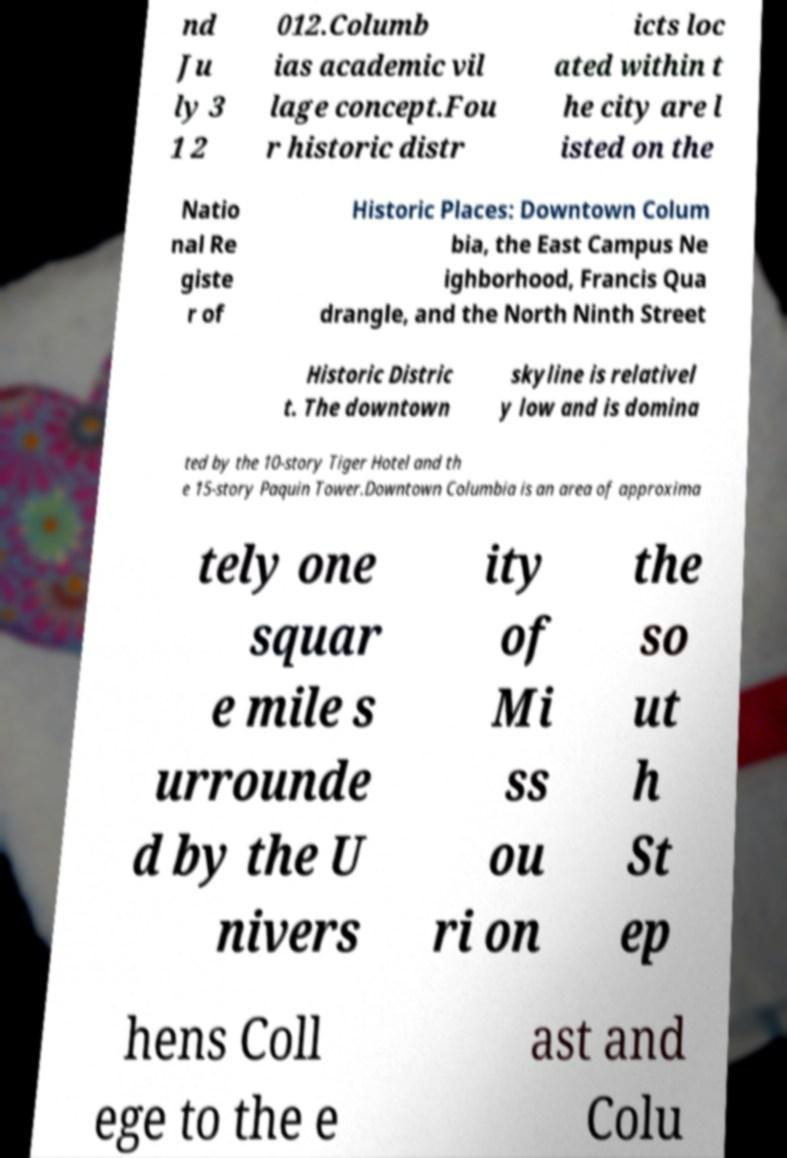What messages or text are displayed in this image? I need them in a readable, typed format. nd Ju ly 3 1 2 012.Columb ias academic vil lage concept.Fou r historic distr icts loc ated within t he city are l isted on the Natio nal Re giste r of Historic Places: Downtown Colum bia, the East Campus Ne ighborhood, Francis Qua drangle, and the North Ninth Street Historic Distric t. The downtown skyline is relativel y low and is domina ted by the 10-story Tiger Hotel and th e 15-story Paquin Tower.Downtown Columbia is an area of approxima tely one squar e mile s urrounde d by the U nivers ity of Mi ss ou ri on the so ut h St ep hens Coll ege to the e ast and Colu 